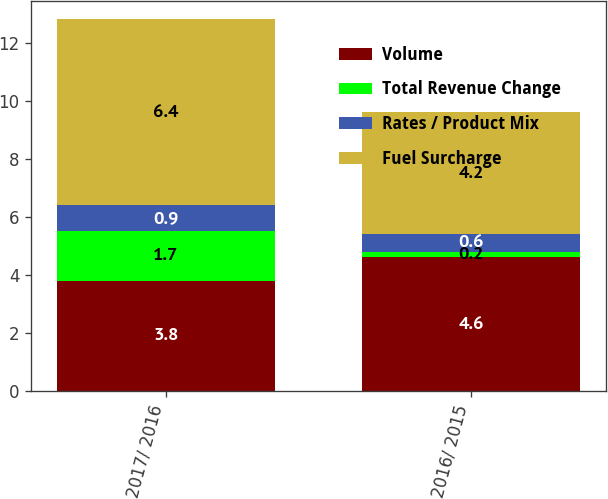Convert chart. <chart><loc_0><loc_0><loc_500><loc_500><stacked_bar_chart><ecel><fcel>2017/ 2016<fcel>2016/ 2015<nl><fcel>Volume<fcel>3.8<fcel>4.6<nl><fcel>Total Revenue Change<fcel>1.7<fcel>0.2<nl><fcel>Rates / Product Mix<fcel>0.9<fcel>0.6<nl><fcel>Fuel Surcharge<fcel>6.4<fcel>4.2<nl></chart> 